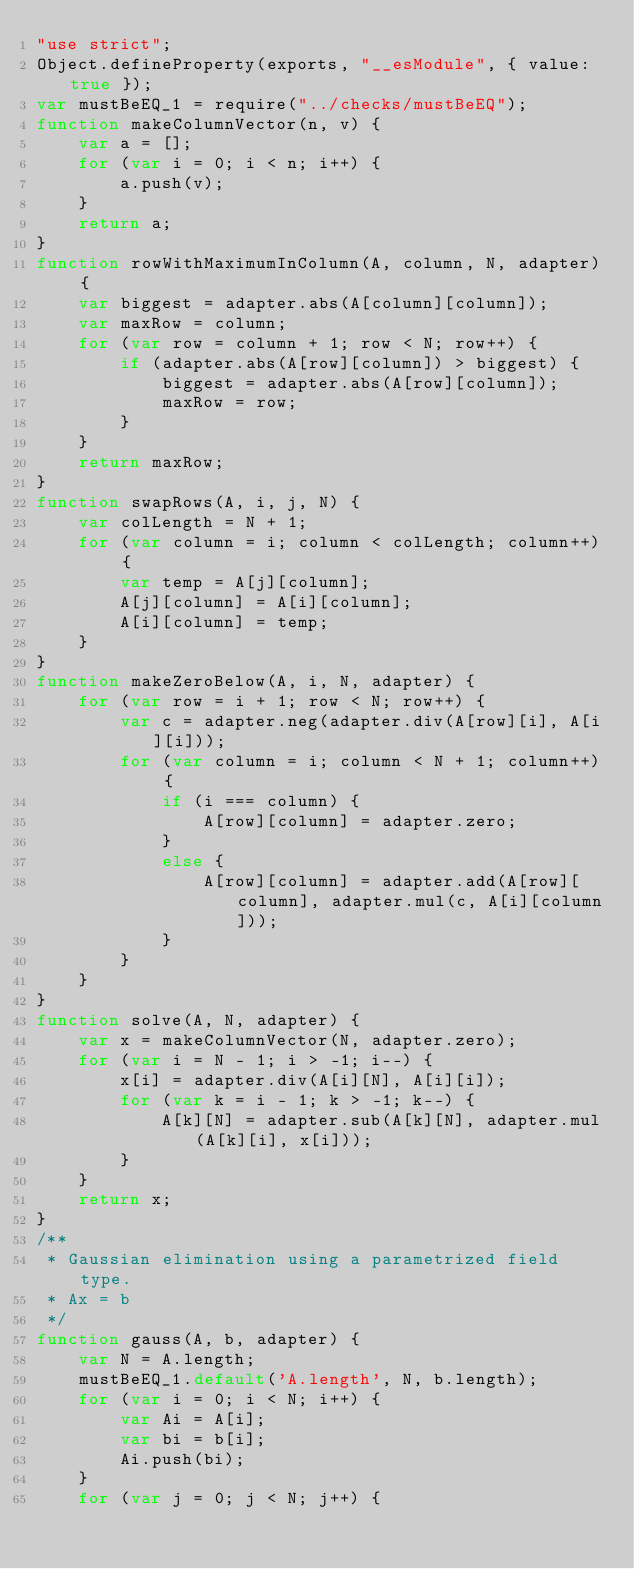<code> <loc_0><loc_0><loc_500><loc_500><_JavaScript_>"use strict";
Object.defineProperty(exports, "__esModule", { value: true });
var mustBeEQ_1 = require("../checks/mustBeEQ");
function makeColumnVector(n, v) {
    var a = [];
    for (var i = 0; i < n; i++) {
        a.push(v);
    }
    return a;
}
function rowWithMaximumInColumn(A, column, N, adapter) {
    var biggest = adapter.abs(A[column][column]);
    var maxRow = column;
    for (var row = column + 1; row < N; row++) {
        if (adapter.abs(A[row][column]) > biggest) {
            biggest = adapter.abs(A[row][column]);
            maxRow = row;
        }
    }
    return maxRow;
}
function swapRows(A, i, j, N) {
    var colLength = N + 1;
    for (var column = i; column < colLength; column++) {
        var temp = A[j][column];
        A[j][column] = A[i][column];
        A[i][column] = temp;
    }
}
function makeZeroBelow(A, i, N, adapter) {
    for (var row = i + 1; row < N; row++) {
        var c = adapter.neg(adapter.div(A[row][i], A[i][i]));
        for (var column = i; column < N + 1; column++) {
            if (i === column) {
                A[row][column] = adapter.zero;
            }
            else {
                A[row][column] = adapter.add(A[row][column], adapter.mul(c, A[i][column]));
            }
        }
    }
}
function solve(A, N, adapter) {
    var x = makeColumnVector(N, adapter.zero);
    for (var i = N - 1; i > -1; i--) {
        x[i] = adapter.div(A[i][N], A[i][i]);
        for (var k = i - 1; k > -1; k--) {
            A[k][N] = adapter.sub(A[k][N], adapter.mul(A[k][i], x[i]));
        }
    }
    return x;
}
/**
 * Gaussian elimination using a parametrized field type.
 * Ax = b
 */
function gauss(A, b, adapter) {
    var N = A.length;
    mustBeEQ_1.default('A.length', N, b.length);
    for (var i = 0; i < N; i++) {
        var Ai = A[i];
        var bi = b[i];
        Ai.push(bi);
    }
    for (var j = 0; j < N; j++) {</code> 